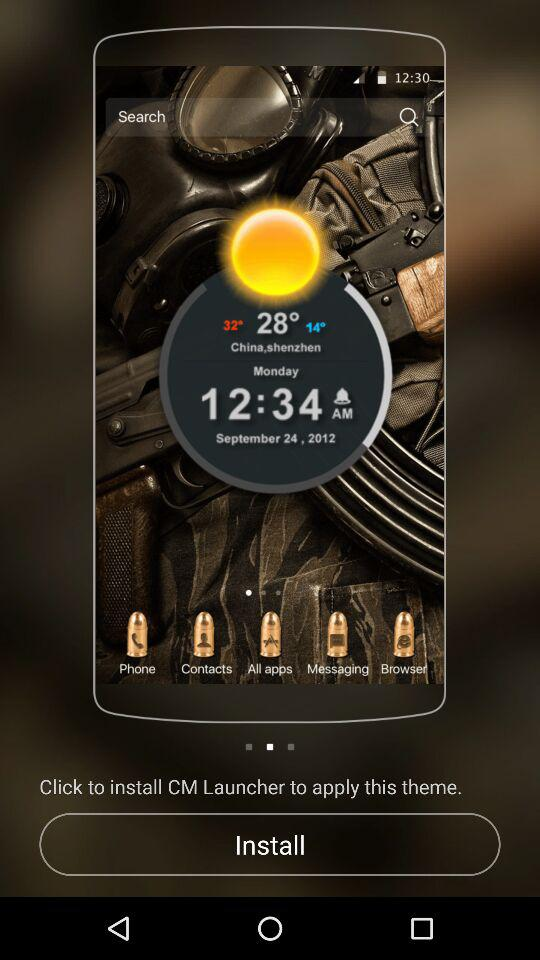What are the mentioned temperatures in Shenzhen? The mentioned temperatures are 32°, 28° and 14°. 